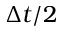Convert formula to latex. <formula><loc_0><loc_0><loc_500><loc_500>\Delta t / 2</formula> 